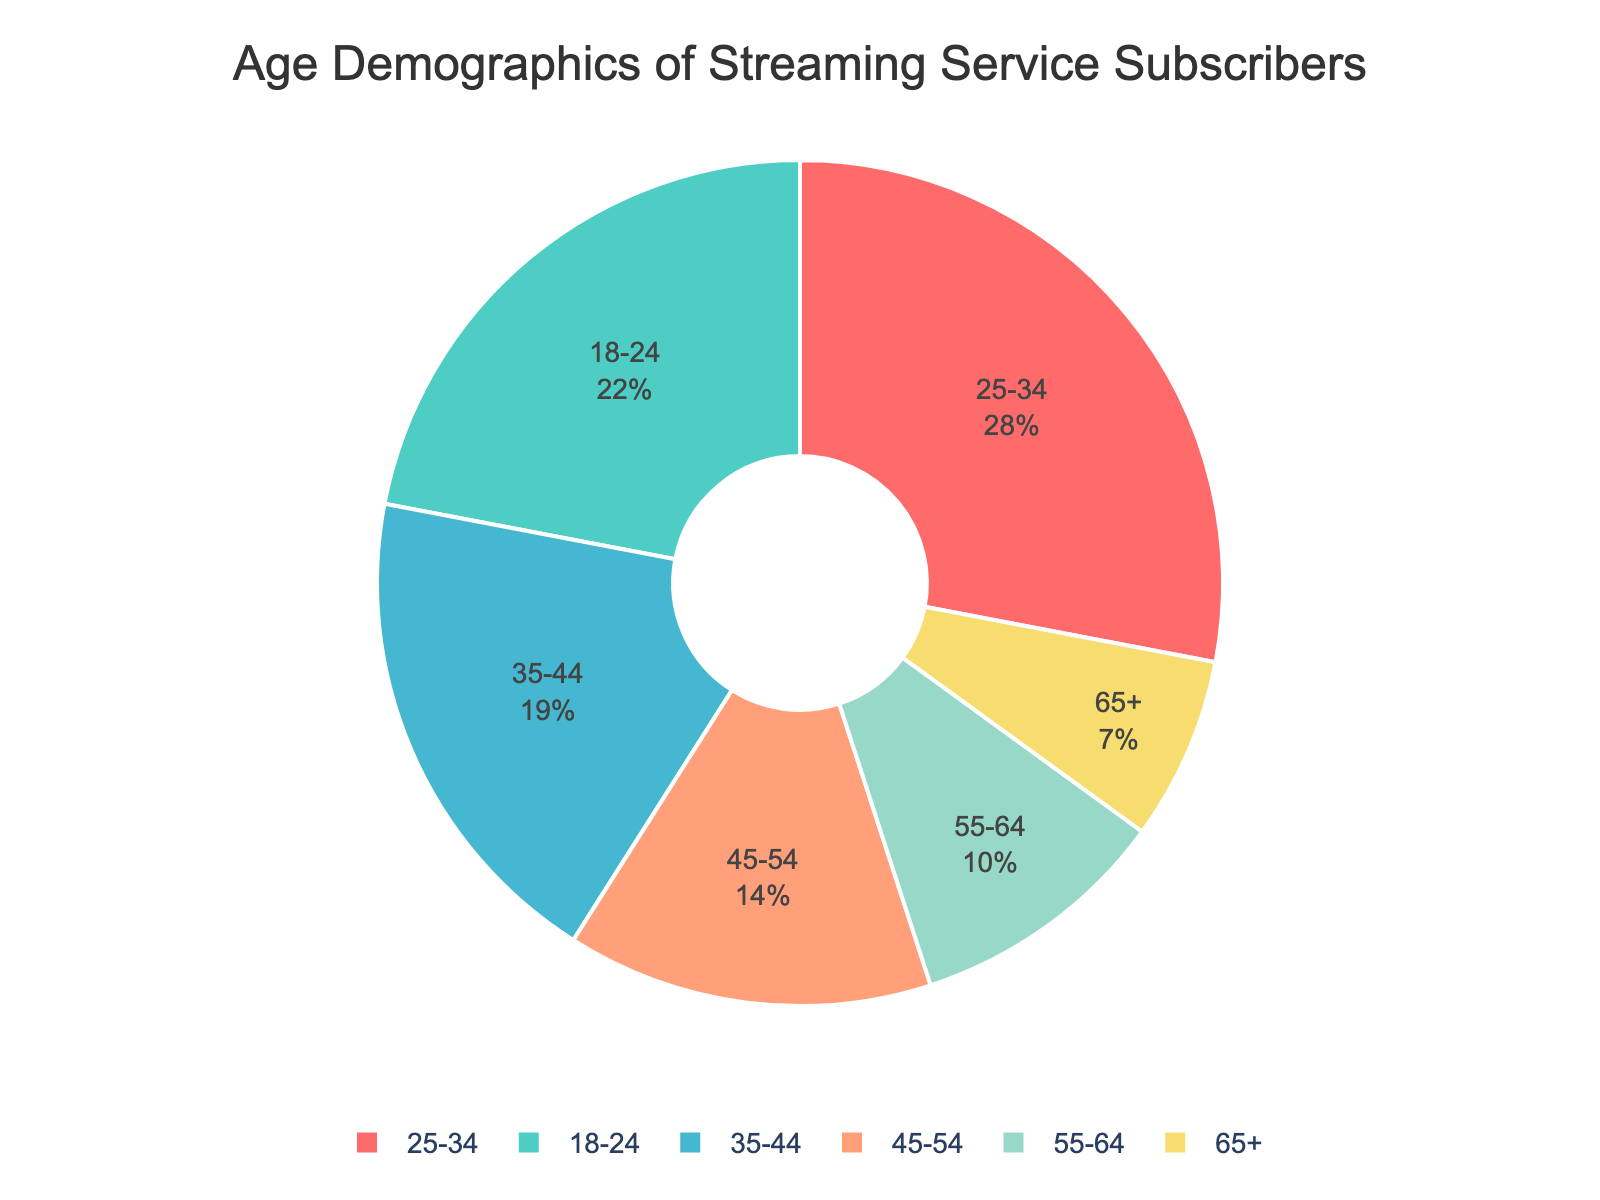What percentage of subscribers are aged 25-34? The pie chart shows the age groups and their corresponding percentages. Find the slice labeled "25-34" and identify the percentage.
Answer: 28% Which age group has the smallest percentage of subscribers? The chart lists all age groups with their respective percentages. Locate the age group with the lowest percentage, which is "65+" with 7%.
Answer: 65+ What is the combined percentage of subscribers aged 35-44 and 45-54? Add the percentages of the 35-44 and 45-54 age groups together. 35-44 is 19% and 45-54 is 14%, so 19% + 14% = 33%.
Answer: 33% Compare the percentages of the 18-24 and 55-64 age groups. Which group has a higher percentage? Look at the percentages for the 18-24 and 55-64 age groups. 18-24 has 22% and 55-64 has 10%. 18-24 is higher.
Answer: 18-24 What is the difference in the percentage of subscribers between 25-34 and 45-54 age groups? Subtract the percentage of the 45-54 age group from the percentage of the 25-34 age group. 28% - 14% = 14%.
Answer: 14% What is the combined percentage of subscribers aged 45 and above? Add the percentages of the age groups 45-54, 55-64, and 65+. 14% + 10% + 7% = 31%.
Answer: 31% Which age group has a larger percentage, 35-44 or 55-64? Compare the percentages of the 35-44 and 55-64 age groups. 35-44 has 19% and 55-64 has 10%. 35-44 is larger.
Answer: 35-44 What is the difference between the percentages of the 18-24 and 25-34 age groups? Subtract the percentage of the 18-24 age group from the percentage of the 25-34 age group. 28% - 22% = 6%.
Answer: 6% Identify the color used for the age group with the highest percentage. Look for the slice with the highest percentage, which is 25-34 at 28%, and identify its color.
Answer: teal What percentage of subscribers are aged under 35? Add the percentages of the 18-24 and 25-34 age groups. 22% + 28% = 50%.
Answer: 50% 